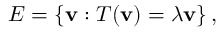<formula> <loc_0><loc_0><loc_500><loc_500>E = \left \{ v \colon T ( v ) = \lambda v \right \} ,</formula> 